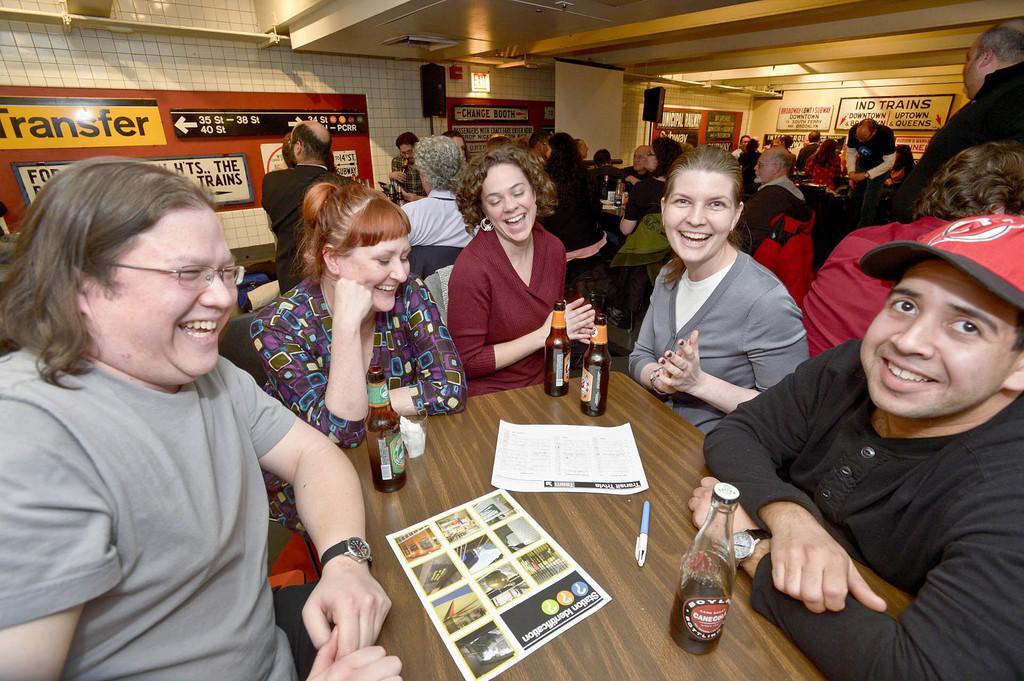Can you describe this image briefly? In this picture we can see a group of people some are sitting and some are standing and in front of them we have table and on table we can see bottle, paper, pen, glass with tissue in it and in the background we can see wall, speaker, light, banners. 